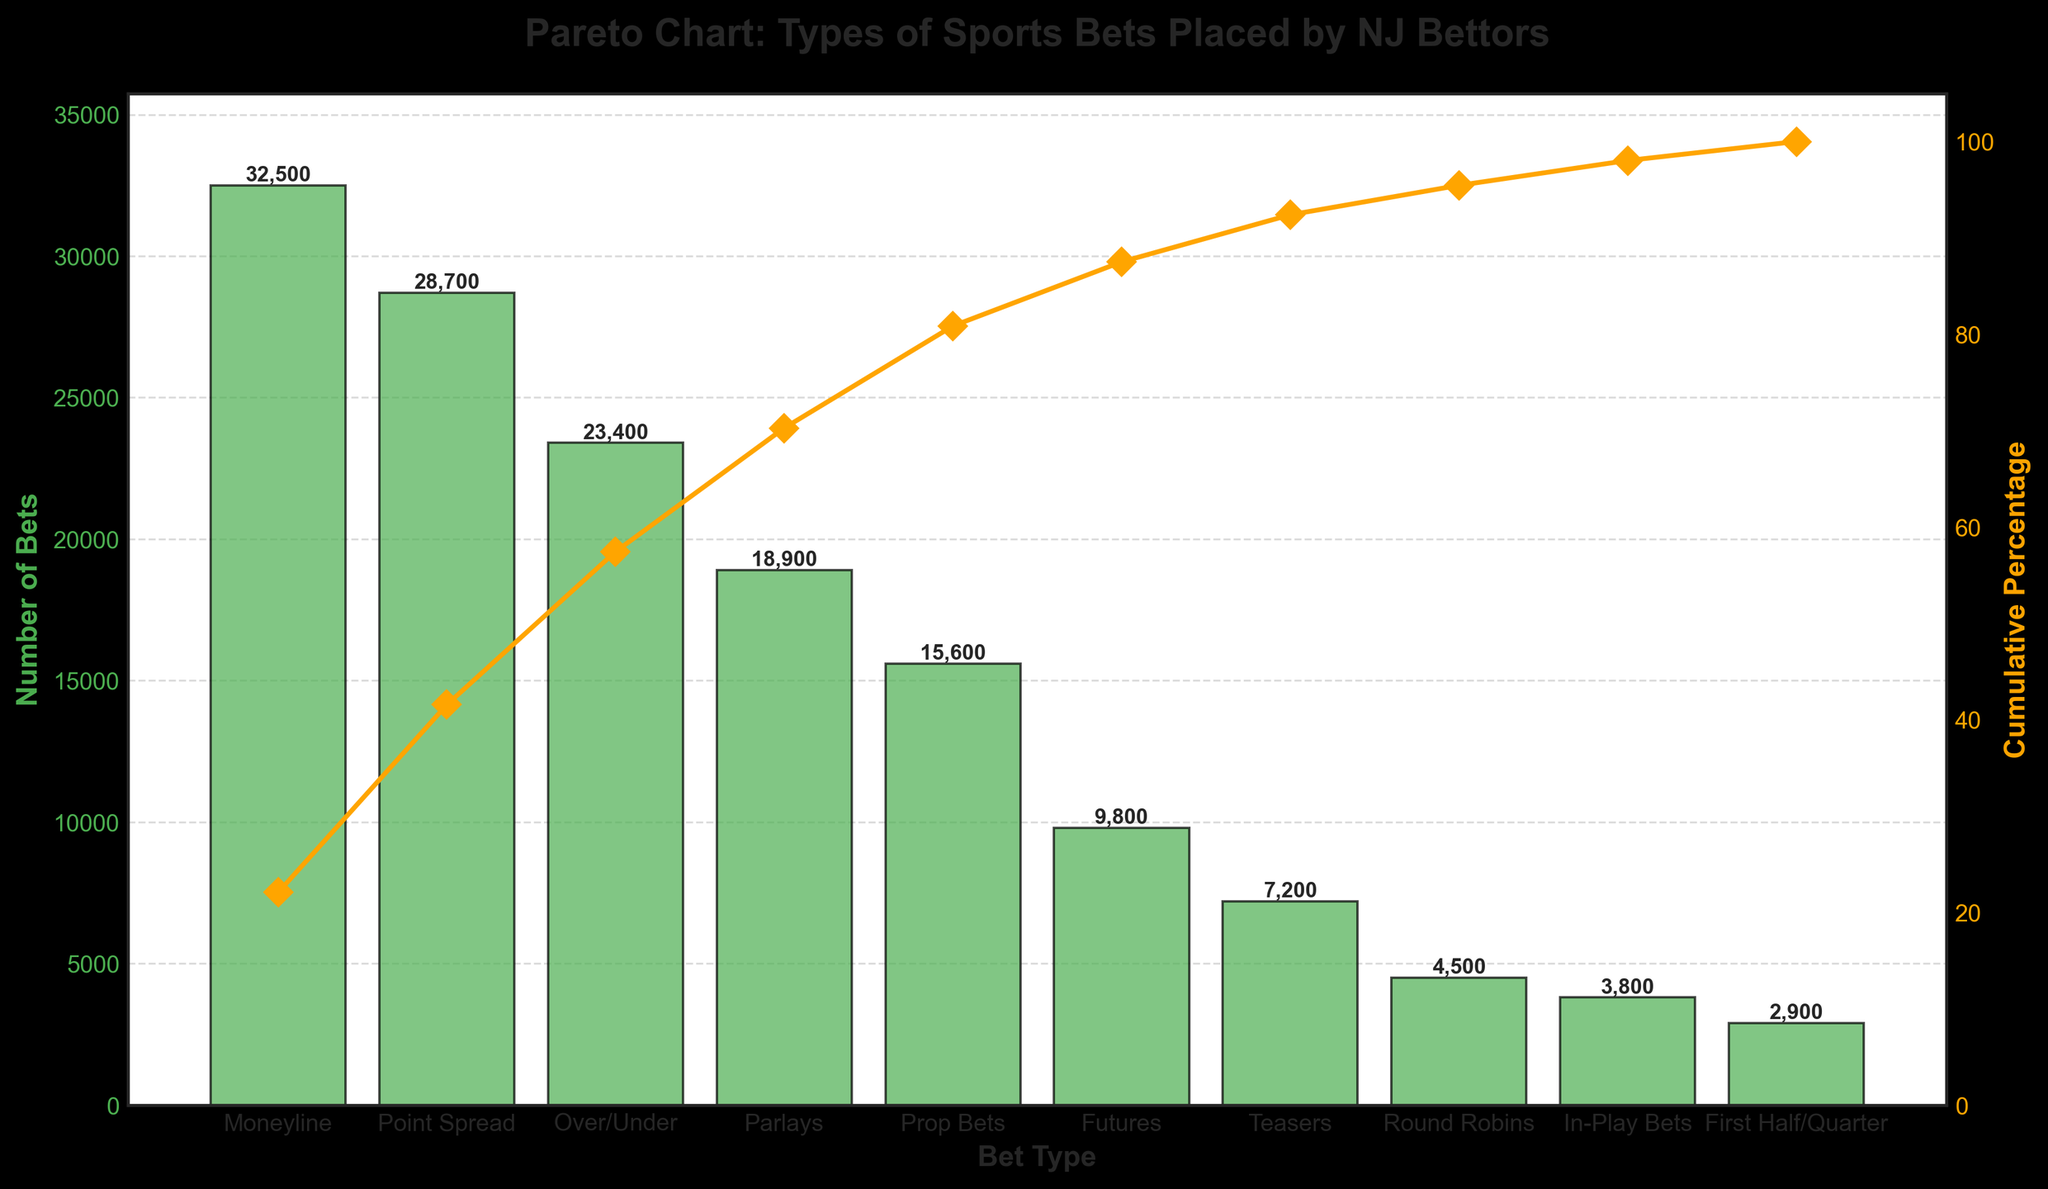what is the title of the chart? The title is typically located at the top of the chart and provides a summary of what the chart represents. In this case, it reads 'Pareto Chart: Types of Sports Bets Placed by NJ Bettors'.
Answer: Pareto Chart: Types of Sports Bets Placed by NJ Bettors how many different bet types are represented in the chart? Count the number of unique bet types along the x-axis. The bars on the chart represent the different types of bets.
Answer: 10 which bet type has the highest number of bets? Look for the tallest bar since it corresponds to the highest value on the secondary y-axis. The label below this bar identifies the bet type.
Answer: Moneyline what is the cumulative percentage after the first three bet types? First, identify the bet types in descending order of bet numbers (Moneyline, Point Spread, Over/Under). Next, refer to the orange cumulative percentage line and find the corresponding y-axis value after the third point.
Answer: 61.7% what is the combined number of bets for Parlays and Prop Bets? Locate the bars for Parlays and Prop Bets to find their number of bets (18900 for Parlays and 15600 for Prop Bets), then add these numbers together.
Answer: 34500 which bet type has the lowest cumulative percentage increase? Examine the orange line and see which segment from one point to the next has the smallest vertical distance. This corresponds to the Round Robins bet type.
Answer: Round Robins is the total number of 'Over/Under' bets more than that of 'Prop Bets' and 'Futures' combined? The number of Over/Under bets is 23,400. Adding Prop Bets (15,600) and Futures (9,800) gives 25,400. Compare these values.
Answer: No how does the number of Point Spread bets compare to Teasers bets? Check the height of the bars for Point Spread (28,700) and Teasers (7,200), then compare them.
Answer: Point Spread bets are greater what percentage of the total is achieved by the combination of the first five bets? Add the number of bets for the first five bet types (Moneyline, Point Spread, Over/Under, Parlays, Prop Bets), then divide this sum by the total number of bets and multiply by 100. Total: (32,500 + 28,700 + 23,400 + 18,900 + 15,600) = 119,100. Total bets = 149,600. So (119,100 / 149,600) * 100 = 79.6%.
Answer: 79.6% what is the difference in the cumulative percentage between Teasers and Round Robins? Identify the cumulative percentage values for Teasers and Round Robins from the orange line. Subtract the percentage for Round Robins from that of Teasers. Roughly 96% for Teasers and 98% for Round Robins; 98% - 96% = 2%.
Answer: 2% 